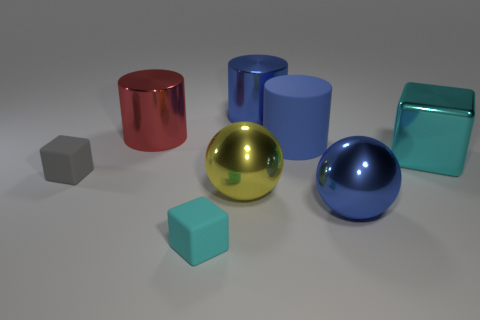Add 1 big blue shiny cylinders. How many objects exist? 9 Subtract all blocks. How many objects are left? 5 Subtract 0 brown cubes. How many objects are left? 8 Subtract all metallic cubes. Subtract all cyan cubes. How many objects are left? 5 Add 7 yellow shiny balls. How many yellow shiny balls are left? 8 Add 3 cubes. How many cubes exist? 6 